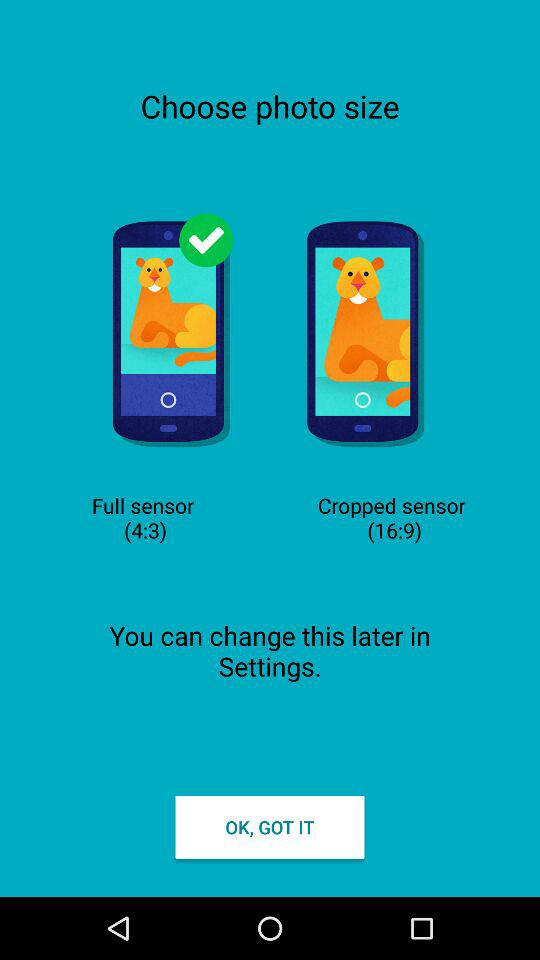What's the ratio of the full sensor image? The ratio is 4:3. 